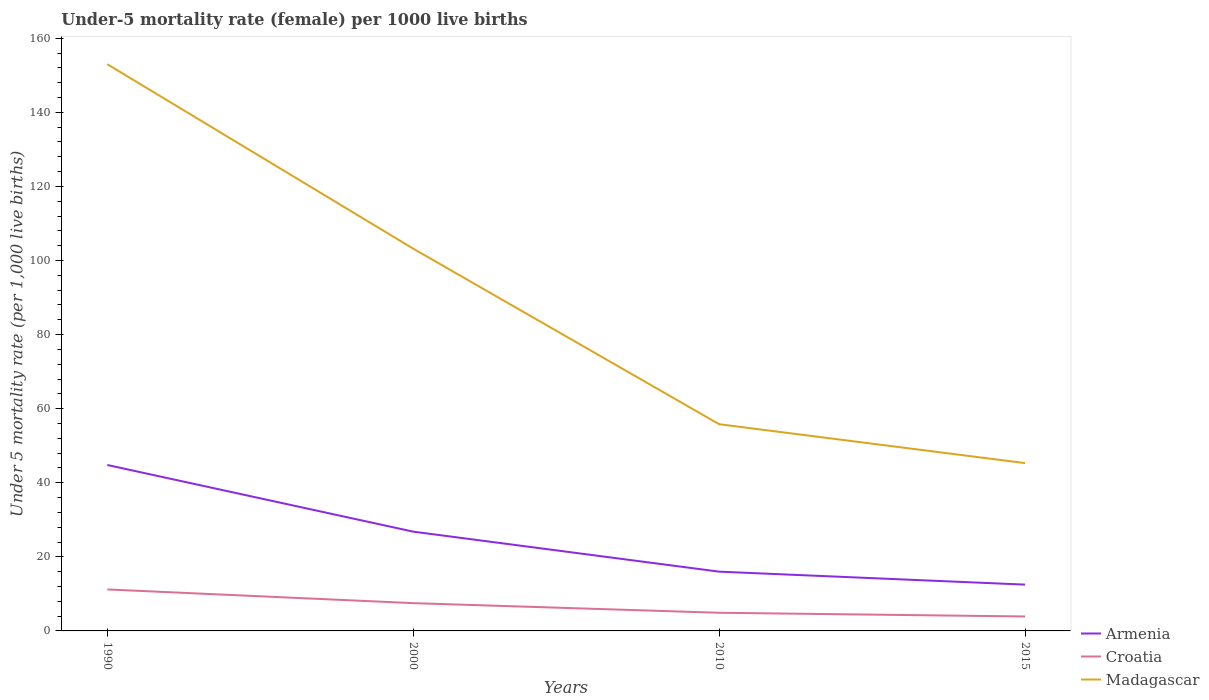How many different coloured lines are there?
Offer a terse response. 3. Does the line corresponding to Armenia intersect with the line corresponding to Madagascar?
Provide a short and direct response. No. In which year was the under-five mortality rate in Madagascar maximum?
Your answer should be very brief. 2015. What is the difference between the highest and the second highest under-five mortality rate in Madagascar?
Offer a terse response. 107.7. What is the difference between the highest and the lowest under-five mortality rate in Armenia?
Offer a very short reply. 2. What is the difference between two consecutive major ticks on the Y-axis?
Offer a terse response. 20. Are the values on the major ticks of Y-axis written in scientific E-notation?
Keep it short and to the point. No. Does the graph contain any zero values?
Ensure brevity in your answer.  No. Where does the legend appear in the graph?
Give a very brief answer. Bottom right. How many legend labels are there?
Your answer should be very brief. 3. What is the title of the graph?
Provide a short and direct response. Under-5 mortality rate (female) per 1000 live births. Does "Italy" appear as one of the legend labels in the graph?
Your answer should be very brief. No. What is the label or title of the X-axis?
Provide a short and direct response. Years. What is the label or title of the Y-axis?
Provide a succinct answer. Under 5 mortality rate (per 1,0 live births). What is the Under 5 mortality rate (per 1,000 live births) in Armenia in 1990?
Give a very brief answer. 44.8. What is the Under 5 mortality rate (per 1,000 live births) of Madagascar in 1990?
Offer a terse response. 153. What is the Under 5 mortality rate (per 1,000 live births) in Armenia in 2000?
Offer a terse response. 26.8. What is the Under 5 mortality rate (per 1,000 live births) of Croatia in 2000?
Your answer should be compact. 7.5. What is the Under 5 mortality rate (per 1,000 live births) of Madagascar in 2000?
Make the answer very short. 103.2. What is the Under 5 mortality rate (per 1,000 live births) in Armenia in 2010?
Provide a short and direct response. 16. What is the Under 5 mortality rate (per 1,000 live births) of Croatia in 2010?
Your response must be concise. 4.9. What is the Under 5 mortality rate (per 1,000 live births) in Madagascar in 2010?
Your answer should be compact. 55.8. What is the Under 5 mortality rate (per 1,000 live births) in Armenia in 2015?
Keep it short and to the point. 12.5. What is the Under 5 mortality rate (per 1,000 live births) in Croatia in 2015?
Offer a very short reply. 3.9. What is the Under 5 mortality rate (per 1,000 live births) of Madagascar in 2015?
Your response must be concise. 45.3. Across all years, what is the maximum Under 5 mortality rate (per 1,000 live births) in Armenia?
Provide a short and direct response. 44.8. Across all years, what is the maximum Under 5 mortality rate (per 1,000 live births) in Croatia?
Provide a succinct answer. 11.2. Across all years, what is the maximum Under 5 mortality rate (per 1,000 live births) in Madagascar?
Offer a terse response. 153. Across all years, what is the minimum Under 5 mortality rate (per 1,000 live births) in Croatia?
Ensure brevity in your answer.  3.9. Across all years, what is the minimum Under 5 mortality rate (per 1,000 live births) of Madagascar?
Provide a succinct answer. 45.3. What is the total Under 5 mortality rate (per 1,000 live births) in Armenia in the graph?
Your response must be concise. 100.1. What is the total Under 5 mortality rate (per 1,000 live births) of Croatia in the graph?
Your answer should be compact. 27.5. What is the total Under 5 mortality rate (per 1,000 live births) of Madagascar in the graph?
Offer a very short reply. 357.3. What is the difference between the Under 5 mortality rate (per 1,000 live births) of Croatia in 1990 and that in 2000?
Make the answer very short. 3.7. What is the difference between the Under 5 mortality rate (per 1,000 live births) in Madagascar in 1990 and that in 2000?
Your answer should be compact. 49.8. What is the difference between the Under 5 mortality rate (per 1,000 live births) in Armenia in 1990 and that in 2010?
Give a very brief answer. 28.8. What is the difference between the Under 5 mortality rate (per 1,000 live births) in Croatia in 1990 and that in 2010?
Give a very brief answer. 6.3. What is the difference between the Under 5 mortality rate (per 1,000 live births) of Madagascar in 1990 and that in 2010?
Keep it short and to the point. 97.2. What is the difference between the Under 5 mortality rate (per 1,000 live births) of Armenia in 1990 and that in 2015?
Give a very brief answer. 32.3. What is the difference between the Under 5 mortality rate (per 1,000 live births) in Croatia in 1990 and that in 2015?
Ensure brevity in your answer.  7.3. What is the difference between the Under 5 mortality rate (per 1,000 live births) of Madagascar in 1990 and that in 2015?
Offer a terse response. 107.7. What is the difference between the Under 5 mortality rate (per 1,000 live births) in Madagascar in 2000 and that in 2010?
Your response must be concise. 47.4. What is the difference between the Under 5 mortality rate (per 1,000 live births) of Madagascar in 2000 and that in 2015?
Ensure brevity in your answer.  57.9. What is the difference between the Under 5 mortality rate (per 1,000 live births) of Croatia in 2010 and that in 2015?
Offer a terse response. 1. What is the difference between the Under 5 mortality rate (per 1,000 live births) in Armenia in 1990 and the Under 5 mortality rate (per 1,000 live births) in Croatia in 2000?
Keep it short and to the point. 37.3. What is the difference between the Under 5 mortality rate (per 1,000 live births) in Armenia in 1990 and the Under 5 mortality rate (per 1,000 live births) in Madagascar in 2000?
Your answer should be compact. -58.4. What is the difference between the Under 5 mortality rate (per 1,000 live births) in Croatia in 1990 and the Under 5 mortality rate (per 1,000 live births) in Madagascar in 2000?
Provide a short and direct response. -92. What is the difference between the Under 5 mortality rate (per 1,000 live births) of Armenia in 1990 and the Under 5 mortality rate (per 1,000 live births) of Croatia in 2010?
Make the answer very short. 39.9. What is the difference between the Under 5 mortality rate (per 1,000 live births) of Croatia in 1990 and the Under 5 mortality rate (per 1,000 live births) of Madagascar in 2010?
Your response must be concise. -44.6. What is the difference between the Under 5 mortality rate (per 1,000 live births) of Armenia in 1990 and the Under 5 mortality rate (per 1,000 live births) of Croatia in 2015?
Your answer should be very brief. 40.9. What is the difference between the Under 5 mortality rate (per 1,000 live births) of Croatia in 1990 and the Under 5 mortality rate (per 1,000 live births) of Madagascar in 2015?
Offer a very short reply. -34.1. What is the difference between the Under 5 mortality rate (per 1,000 live births) of Armenia in 2000 and the Under 5 mortality rate (per 1,000 live births) of Croatia in 2010?
Your answer should be compact. 21.9. What is the difference between the Under 5 mortality rate (per 1,000 live births) of Armenia in 2000 and the Under 5 mortality rate (per 1,000 live births) of Madagascar in 2010?
Provide a short and direct response. -29. What is the difference between the Under 5 mortality rate (per 1,000 live births) of Croatia in 2000 and the Under 5 mortality rate (per 1,000 live births) of Madagascar in 2010?
Ensure brevity in your answer.  -48.3. What is the difference between the Under 5 mortality rate (per 1,000 live births) of Armenia in 2000 and the Under 5 mortality rate (per 1,000 live births) of Croatia in 2015?
Make the answer very short. 22.9. What is the difference between the Under 5 mortality rate (per 1,000 live births) in Armenia in 2000 and the Under 5 mortality rate (per 1,000 live births) in Madagascar in 2015?
Your answer should be very brief. -18.5. What is the difference between the Under 5 mortality rate (per 1,000 live births) of Croatia in 2000 and the Under 5 mortality rate (per 1,000 live births) of Madagascar in 2015?
Offer a very short reply. -37.8. What is the difference between the Under 5 mortality rate (per 1,000 live births) of Armenia in 2010 and the Under 5 mortality rate (per 1,000 live births) of Croatia in 2015?
Make the answer very short. 12.1. What is the difference between the Under 5 mortality rate (per 1,000 live births) in Armenia in 2010 and the Under 5 mortality rate (per 1,000 live births) in Madagascar in 2015?
Keep it short and to the point. -29.3. What is the difference between the Under 5 mortality rate (per 1,000 live births) of Croatia in 2010 and the Under 5 mortality rate (per 1,000 live births) of Madagascar in 2015?
Your answer should be very brief. -40.4. What is the average Under 5 mortality rate (per 1,000 live births) of Armenia per year?
Your answer should be compact. 25.02. What is the average Under 5 mortality rate (per 1,000 live births) in Croatia per year?
Make the answer very short. 6.88. What is the average Under 5 mortality rate (per 1,000 live births) of Madagascar per year?
Your response must be concise. 89.33. In the year 1990, what is the difference between the Under 5 mortality rate (per 1,000 live births) of Armenia and Under 5 mortality rate (per 1,000 live births) of Croatia?
Offer a very short reply. 33.6. In the year 1990, what is the difference between the Under 5 mortality rate (per 1,000 live births) of Armenia and Under 5 mortality rate (per 1,000 live births) of Madagascar?
Offer a terse response. -108.2. In the year 1990, what is the difference between the Under 5 mortality rate (per 1,000 live births) in Croatia and Under 5 mortality rate (per 1,000 live births) in Madagascar?
Keep it short and to the point. -141.8. In the year 2000, what is the difference between the Under 5 mortality rate (per 1,000 live births) of Armenia and Under 5 mortality rate (per 1,000 live births) of Croatia?
Your answer should be compact. 19.3. In the year 2000, what is the difference between the Under 5 mortality rate (per 1,000 live births) in Armenia and Under 5 mortality rate (per 1,000 live births) in Madagascar?
Offer a very short reply. -76.4. In the year 2000, what is the difference between the Under 5 mortality rate (per 1,000 live births) in Croatia and Under 5 mortality rate (per 1,000 live births) in Madagascar?
Make the answer very short. -95.7. In the year 2010, what is the difference between the Under 5 mortality rate (per 1,000 live births) in Armenia and Under 5 mortality rate (per 1,000 live births) in Madagascar?
Keep it short and to the point. -39.8. In the year 2010, what is the difference between the Under 5 mortality rate (per 1,000 live births) of Croatia and Under 5 mortality rate (per 1,000 live births) of Madagascar?
Make the answer very short. -50.9. In the year 2015, what is the difference between the Under 5 mortality rate (per 1,000 live births) of Armenia and Under 5 mortality rate (per 1,000 live births) of Croatia?
Your answer should be very brief. 8.6. In the year 2015, what is the difference between the Under 5 mortality rate (per 1,000 live births) in Armenia and Under 5 mortality rate (per 1,000 live births) in Madagascar?
Offer a terse response. -32.8. In the year 2015, what is the difference between the Under 5 mortality rate (per 1,000 live births) of Croatia and Under 5 mortality rate (per 1,000 live births) of Madagascar?
Keep it short and to the point. -41.4. What is the ratio of the Under 5 mortality rate (per 1,000 live births) of Armenia in 1990 to that in 2000?
Your answer should be compact. 1.67. What is the ratio of the Under 5 mortality rate (per 1,000 live births) in Croatia in 1990 to that in 2000?
Your response must be concise. 1.49. What is the ratio of the Under 5 mortality rate (per 1,000 live births) of Madagascar in 1990 to that in 2000?
Offer a terse response. 1.48. What is the ratio of the Under 5 mortality rate (per 1,000 live births) in Croatia in 1990 to that in 2010?
Your answer should be compact. 2.29. What is the ratio of the Under 5 mortality rate (per 1,000 live births) of Madagascar in 1990 to that in 2010?
Provide a short and direct response. 2.74. What is the ratio of the Under 5 mortality rate (per 1,000 live births) of Armenia in 1990 to that in 2015?
Offer a very short reply. 3.58. What is the ratio of the Under 5 mortality rate (per 1,000 live births) in Croatia in 1990 to that in 2015?
Offer a very short reply. 2.87. What is the ratio of the Under 5 mortality rate (per 1,000 live births) of Madagascar in 1990 to that in 2015?
Ensure brevity in your answer.  3.38. What is the ratio of the Under 5 mortality rate (per 1,000 live births) in Armenia in 2000 to that in 2010?
Offer a terse response. 1.68. What is the ratio of the Under 5 mortality rate (per 1,000 live births) of Croatia in 2000 to that in 2010?
Your answer should be compact. 1.53. What is the ratio of the Under 5 mortality rate (per 1,000 live births) of Madagascar in 2000 to that in 2010?
Provide a short and direct response. 1.85. What is the ratio of the Under 5 mortality rate (per 1,000 live births) of Armenia in 2000 to that in 2015?
Your response must be concise. 2.14. What is the ratio of the Under 5 mortality rate (per 1,000 live births) in Croatia in 2000 to that in 2015?
Provide a short and direct response. 1.92. What is the ratio of the Under 5 mortality rate (per 1,000 live births) of Madagascar in 2000 to that in 2015?
Ensure brevity in your answer.  2.28. What is the ratio of the Under 5 mortality rate (per 1,000 live births) in Armenia in 2010 to that in 2015?
Provide a succinct answer. 1.28. What is the ratio of the Under 5 mortality rate (per 1,000 live births) in Croatia in 2010 to that in 2015?
Your answer should be compact. 1.26. What is the ratio of the Under 5 mortality rate (per 1,000 live births) of Madagascar in 2010 to that in 2015?
Offer a terse response. 1.23. What is the difference between the highest and the second highest Under 5 mortality rate (per 1,000 live births) of Armenia?
Keep it short and to the point. 18. What is the difference between the highest and the second highest Under 5 mortality rate (per 1,000 live births) in Croatia?
Ensure brevity in your answer.  3.7. What is the difference between the highest and the second highest Under 5 mortality rate (per 1,000 live births) in Madagascar?
Your response must be concise. 49.8. What is the difference between the highest and the lowest Under 5 mortality rate (per 1,000 live births) in Armenia?
Your response must be concise. 32.3. What is the difference between the highest and the lowest Under 5 mortality rate (per 1,000 live births) of Croatia?
Ensure brevity in your answer.  7.3. What is the difference between the highest and the lowest Under 5 mortality rate (per 1,000 live births) in Madagascar?
Offer a terse response. 107.7. 